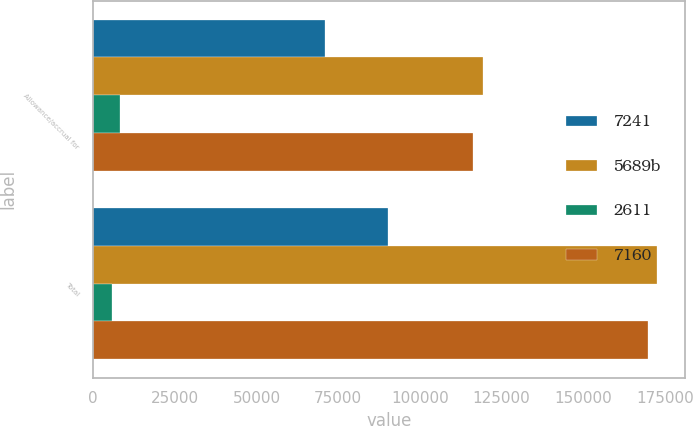Convert chart. <chart><loc_0><loc_0><loc_500><loc_500><stacked_bar_chart><ecel><fcel>Allowance/accrual for<fcel>Total<nl><fcel>7241<fcel>70945<fcel>90212<nl><fcel>5689b<fcel>119267<fcel>172615<nl><fcel>2611<fcel>8233<fcel>5745<nl><fcel>7160<fcel>116200<fcel>169712<nl></chart> 